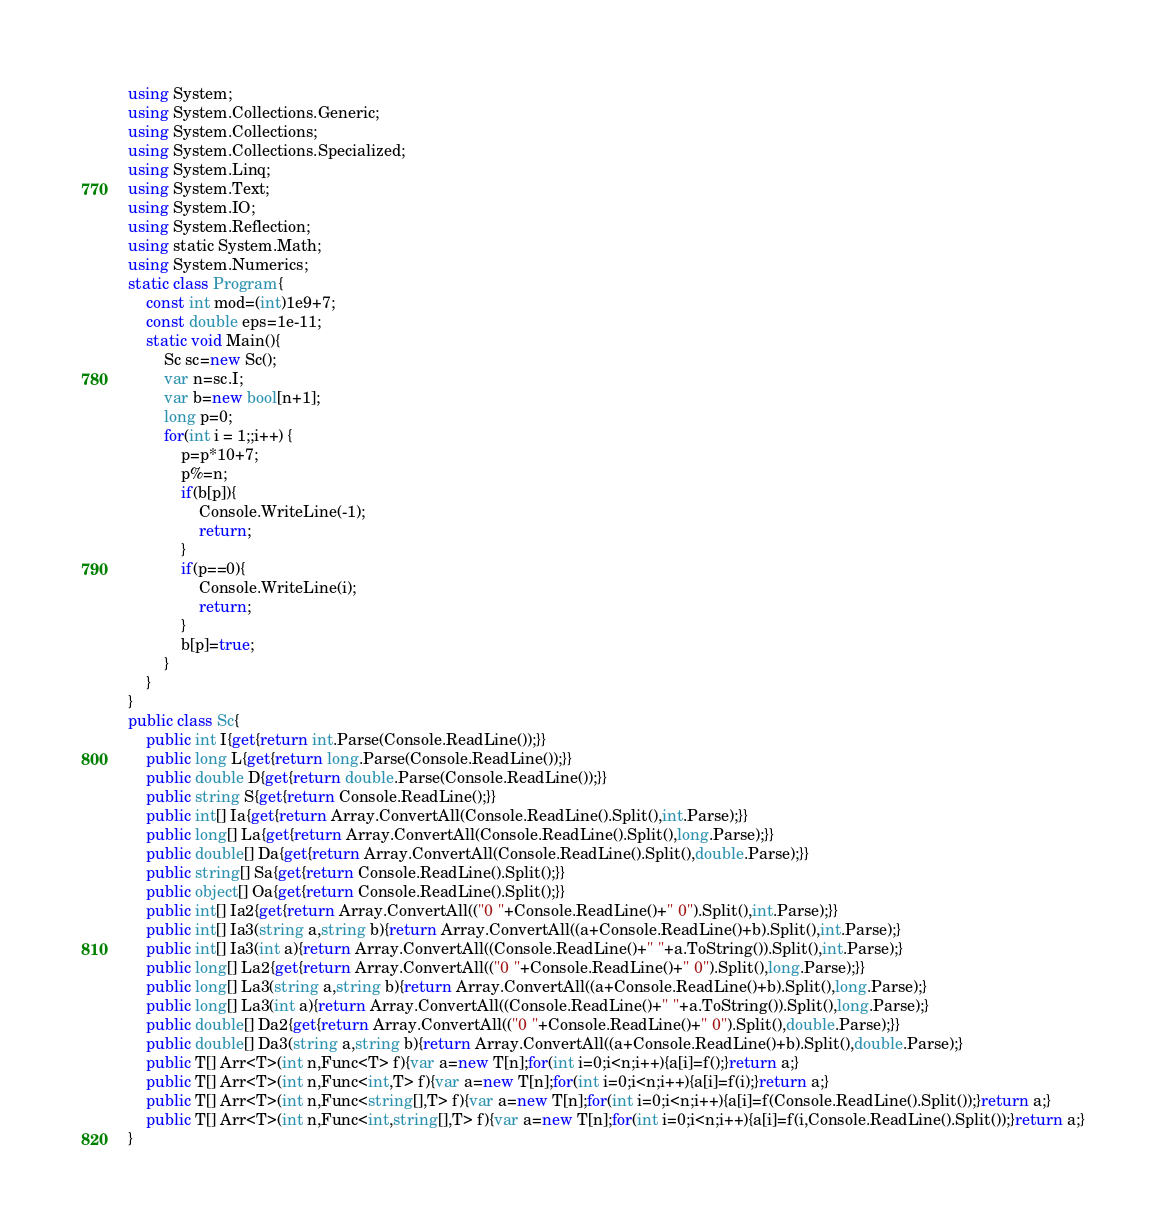Convert code to text. <code><loc_0><loc_0><loc_500><loc_500><_C#_>using System;
using System.Collections.Generic;
using System.Collections;
using System.Collections.Specialized;
using System.Linq;
using System.Text;
using System.IO;
using System.Reflection;
using static System.Math;
using System.Numerics;
static class Program{
	const int mod=(int)1e9+7;
	const double eps=1e-11;
	static void Main(){
		Sc sc=new Sc();
		var n=sc.I;
		var b=new bool[n+1];
		long p=0;
		for(int i = 1;;i++) {
			p=p*10+7;
			p%=n;
			if(b[p]){
				Console.WriteLine(-1);
				return;
			}
			if(p==0){
				Console.WriteLine(i);
				return;
			}
			b[p]=true;
		}
	}
}
public class Sc{
	public int I{get{return int.Parse(Console.ReadLine());}}
	public long L{get{return long.Parse(Console.ReadLine());}}
	public double D{get{return double.Parse(Console.ReadLine());}}
	public string S{get{return Console.ReadLine();}}
	public int[] Ia{get{return Array.ConvertAll(Console.ReadLine().Split(),int.Parse);}}
	public long[] La{get{return Array.ConvertAll(Console.ReadLine().Split(),long.Parse);}}
	public double[] Da{get{return Array.ConvertAll(Console.ReadLine().Split(),double.Parse);}}
	public string[] Sa{get{return Console.ReadLine().Split();}}
	public object[] Oa{get{return Console.ReadLine().Split();}}
	public int[] Ia2{get{return Array.ConvertAll(("0 "+Console.ReadLine()+" 0").Split(),int.Parse);}}
	public int[] Ia3(string a,string b){return Array.ConvertAll((a+Console.ReadLine()+b).Split(),int.Parse);}
	public int[] Ia3(int a){return Array.ConvertAll((Console.ReadLine()+" "+a.ToString()).Split(),int.Parse);}
	public long[] La2{get{return Array.ConvertAll(("0 "+Console.ReadLine()+" 0").Split(),long.Parse);}}
	public long[] La3(string a,string b){return Array.ConvertAll((a+Console.ReadLine()+b).Split(),long.Parse);}
	public long[] La3(int a){return Array.ConvertAll((Console.ReadLine()+" "+a.ToString()).Split(),long.Parse);}
	public double[] Da2{get{return Array.ConvertAll(("0 "+Console.ReadLine()+" 0").Split(),double.Parse);}}
	public double[] Da3(string a,string b){return Array.ConvertAll((a+Console.ReadLine()+b).Split(),double.Parse);}
	public T[] Arr<T>(int n,Func<T> f){var a=new T[n];for(int i=0;i<n;i++){a[i]=f();}return a;}
	public T[] Arr<T>(int n,Func<int,T> f){var a=new T[n];for(int i=0;i<n;i++){a[i]=f(i);}return a;}
	public T[] Arr<T>(int n,Func<string[],T> f){var a=new T[n];for(int i=0;i<n;i++){a[i]=f(Console.ReadLine().Split());}return a;}
	public T[] Arr<T>(int n,Func<int,string[],T> f){var a=new T[n];for(int i=0;i<n;i++){a[i]=f(i,Console.ReadLine().Split());}return a;}
}</code> 